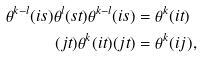Convert formula to latex. <formula><loc_0><loc_0><loc_500><loc_500>\theta ^ { k - l } ( i s ) \theta ^ { l } ( s t ) \theta ^ { k - l } ( i s ) & = \theta ^ { k } ( i t ) \\ ( j t ) \theta ^ { k } ( i t ) ( j t ) & = \theta ^ { k } ( i j ) ,</formula> 